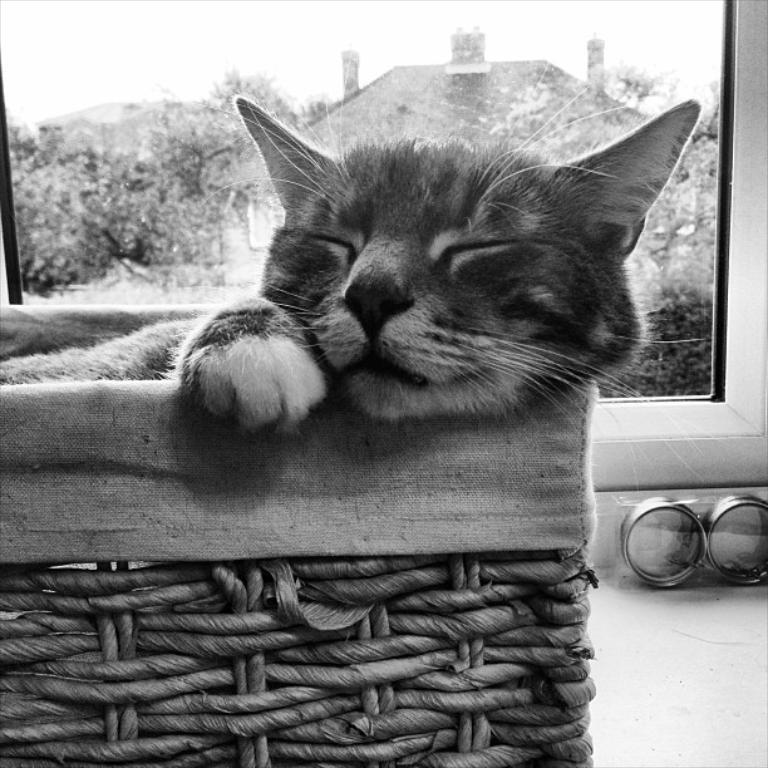What is the color scheme of the image? The image is black and white. What animal can be seen in the image? There is a cat in the image. What is the cat doing in the image? The cat is sleeping on a chair. What can be seen in the background of the image? There are trees, a house, and the sky visible in the background of the image. What type of game is being played in the image? There is no game being played in the image; it features a cat sleeping on a chair. What kind of plantation can be seen in the background of the image? There is no plantation present in the image; it shows trees, a house, and the sky in the background. 